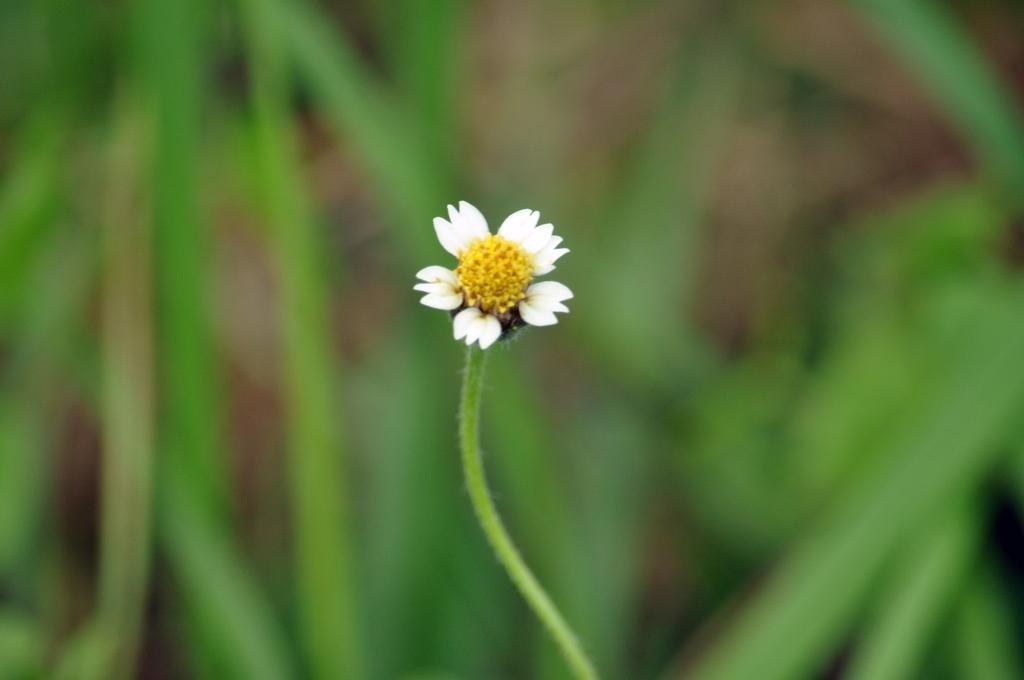What is the main subject of the image? There is a flower in the image. Can you describe the colors of the flower? The flower has yellow and white colors. What else can be seen in the background of the image? There are leaves in the background of the image. How are the leaves depicted in the image? The leaves are blurred. What story is being told by the receipt in the image? There is no receipt present in the image, so no story can be told from it. 